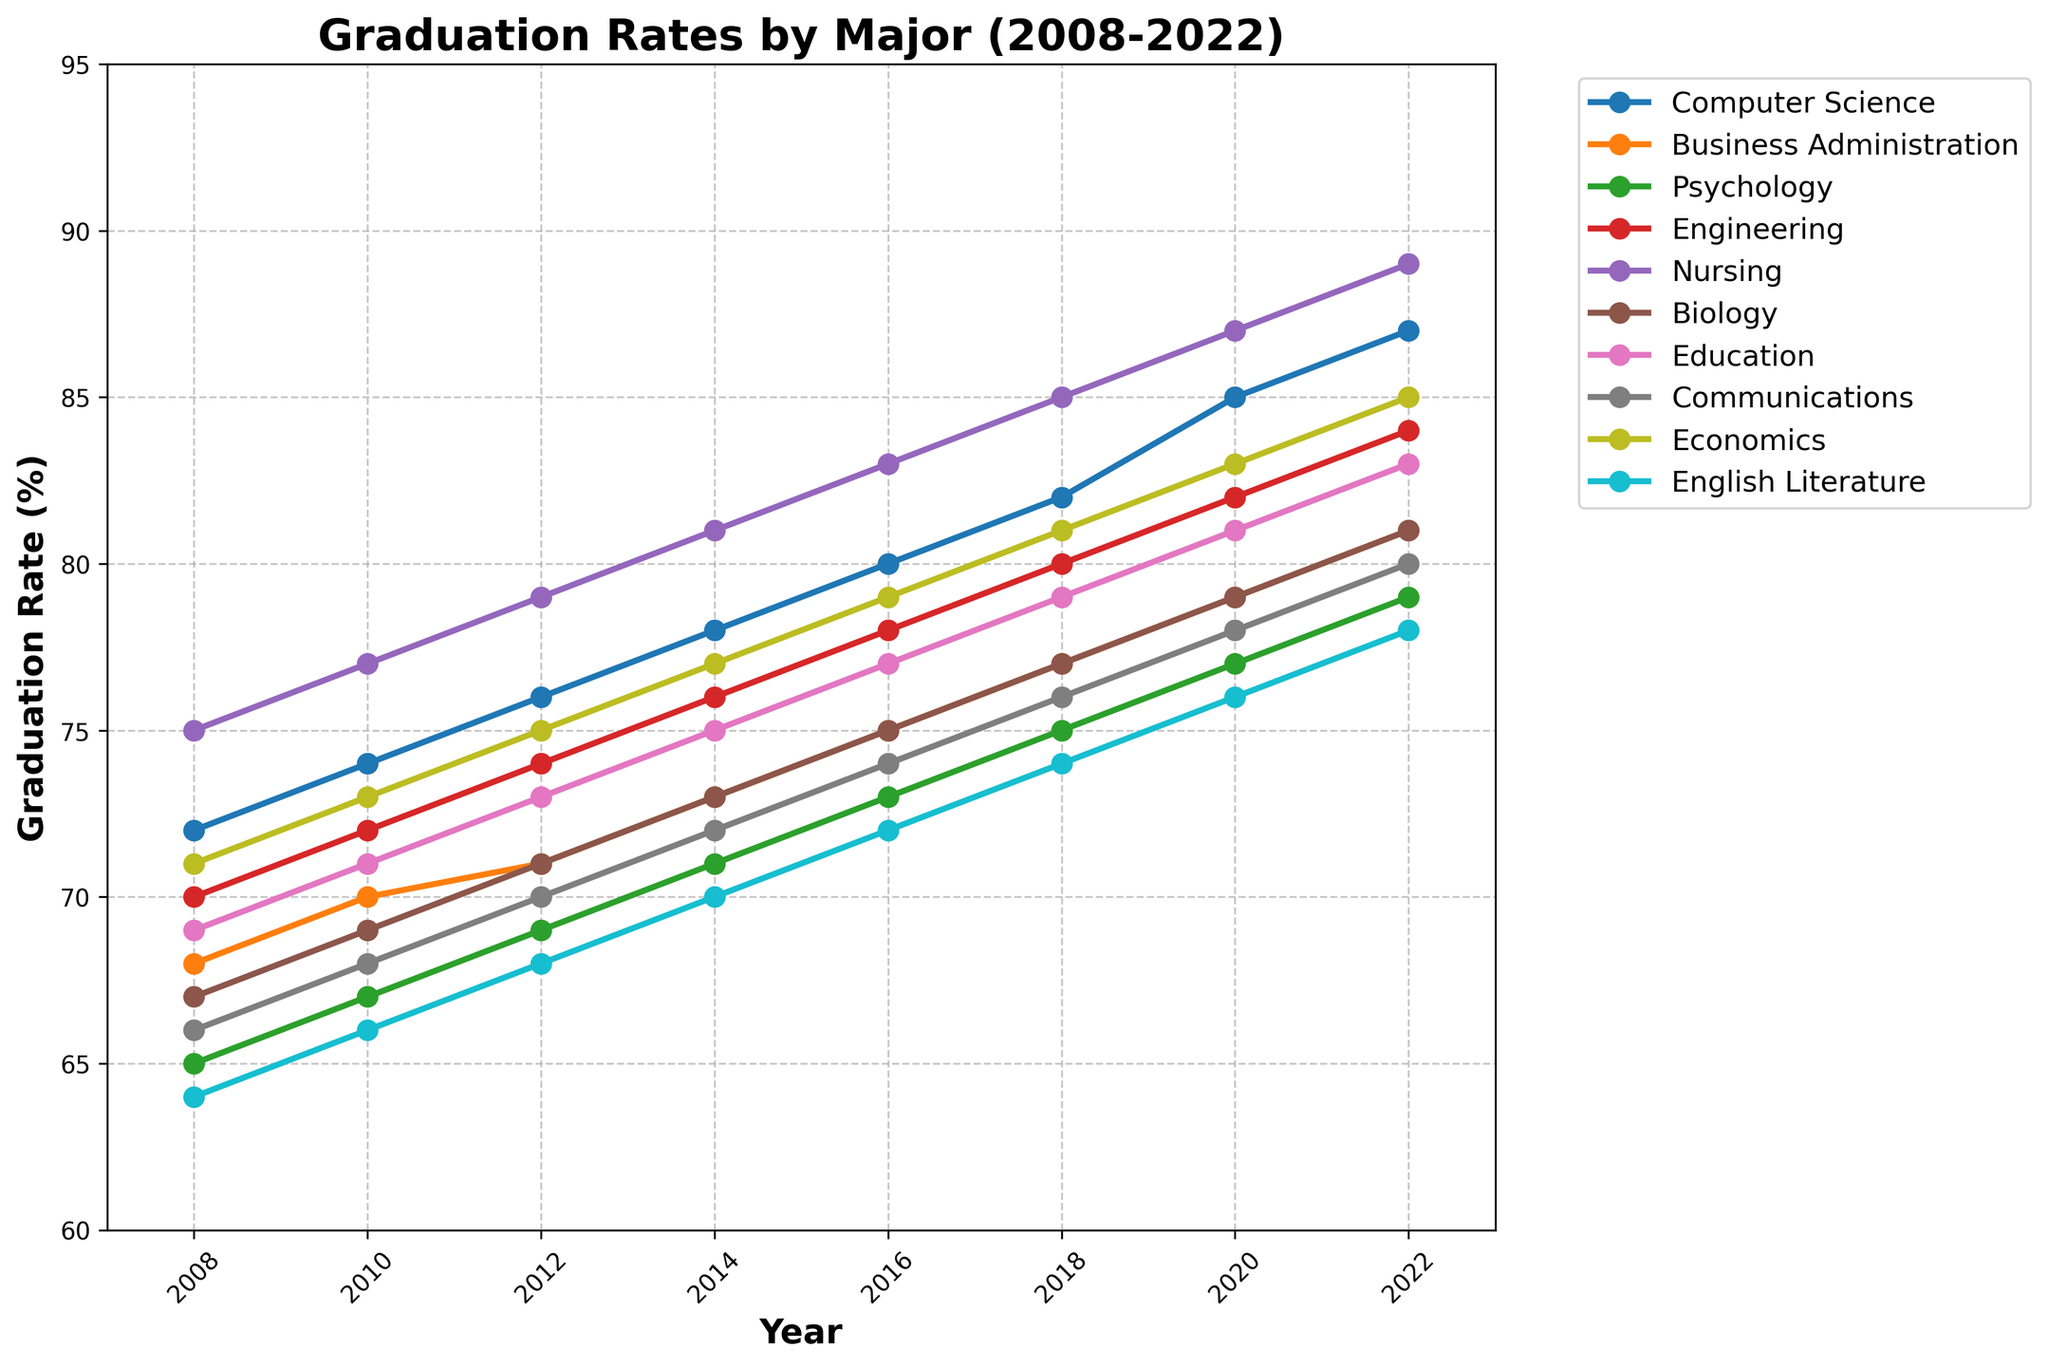What major had the highest graduation rate in 2022? All data points for 2022 need to be checked. Nursing has the highest graduation rate at 89%.
Answer: Nursing Which major showed the greatest improvement in graduation rates from 2008 to 2022? Calculate the difference in graduation rates from 2008 to 2022 for each major. Computer Science shows the greatest improvement of 15 percentage points (87 - 72).
Answer: Computer Science Which year shows the most significant increase in graduation rates for Business Administration? Review the plotted line for Business Administration to identify the year with the steepest increase. The year 2008-2010 shows the largest increase from 68% to 70%.
Answer: 2010 On average, how much did the graduation rate for Engineering improve every two years from 2008 to 2022? Calculate the overall improvement (84 - 70 = 14) and divide by the number of 2-year intervals (7). The average improvement is 14/7 ≈ 2 percentage points every two years.
Answer: 2 Which major had the least improvement in graduation rates from 2008 to 2022? Calculate the difference for each major and determine the minimum. English Literature had the least improvement of 14 percentage points (78 - 64).
Answer: English Literature Did any major have a consistent increase in graduation rates every two years? Review the trends for each major to check for consistent increases without any drops. All majors showed consistent increases; however, Nursing showed a steady increase without any fluctuation.
Answer: Nursing In 2016, which major had a higher graduation rate, Biology or Economics? Compare the data points for 2016 for both majors. Economics had a higher rate at 79% compared to Biology's 75%.
Answer: Economics By how many percentage points did the graduation rate for Communications increase from 2008 to 2022? Subtract the 2008 value from the 2022 value for Communications. The rate increased from 66% to 80%, an increase of 14 percentage points.
Answer: 14 What is the average graduation rate for Psychology over the period 2008 to 2022? Add the values for Psychology and divide by the number of values (8). The sum is 576, and the average is 576/8 = 72%.
Answer: 72 Which major had a higher graduation rate in 2022, Nursing or Computer Science? Compare the 2022 data points for both majors. Nursing had a rate of 89%, while Computer Science had 87%. So, Nursing is higher.
Answer: Nursing 